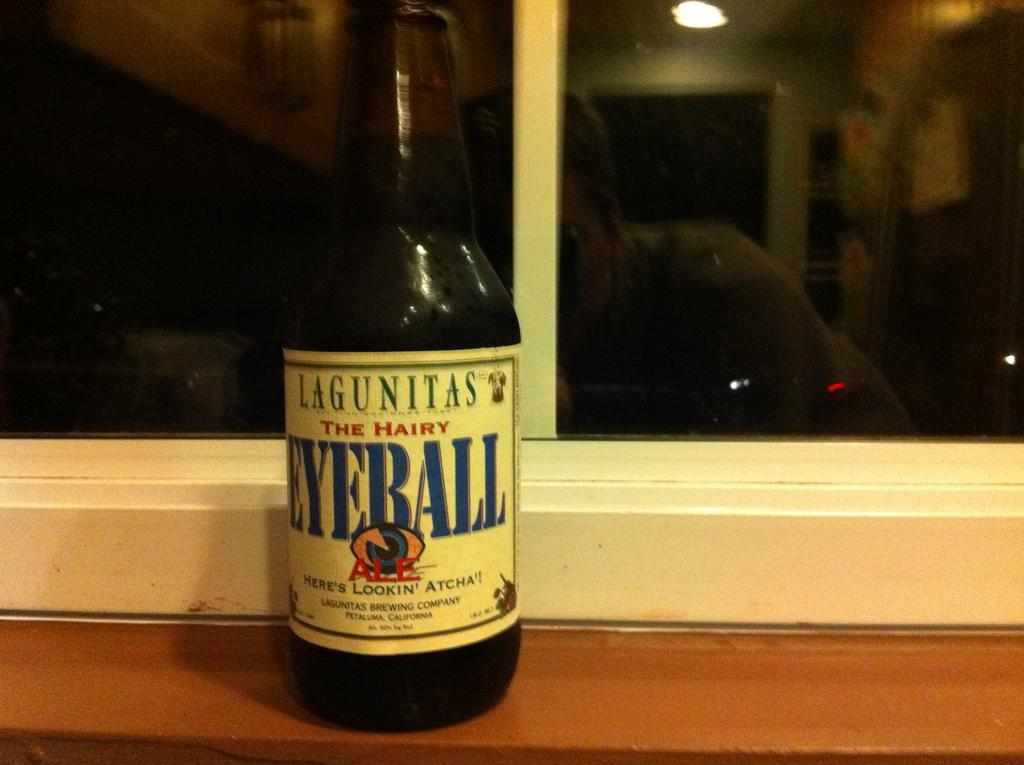What is on the bottle in the image? There is a sticker on the bottle in the image. What can be seen in the background of the image? There is a window in the background of the image. What is visible in the reflection on the window? A reflection of a person, light, and other objects are visible in the reflection on the window. What type of heart can be seen beating in the image? There is no heart visible in the image. 